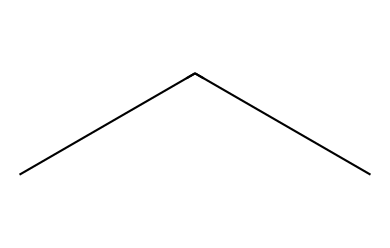What is the name of the chemical represented by this structure? The structure is characterized by the presence of repeating carbon units, specifically with side chains, typical of polyethylene.
Answer: polyethylene How many carbon atoms are present in this chemical? The SMILES representation indicates the presence of two carbon atoms in the main chain. However, including the branching, the total count is three carbon atoms.
Answer: three What type of polymer is this chemical classified as? Due to its repeating ethylene units without significant branching in its primary structure, it is classified as a linear or low-density polyethylene.
Answer: linear What is the primary use of this polymer in urban planning? This polymer is widely used for manufacturing containers due to its durability and resistance to water, making it suitable for emergency storage applications.
Answer: storage containers What is the degree of saturation of this chemical? The structure is fully saturated as it contains only single bonds between the carbon atoms, indicating that all carbon atoms are bonded to the maximum number of hydrogen atoms.
Answer: saturated What properties make this polymer suitable for disaster preparedness? Its resistance to moisture and high tensile strength make it particularly effective for storing water during emergencies in urban settings.
Answer: moisture resistance 